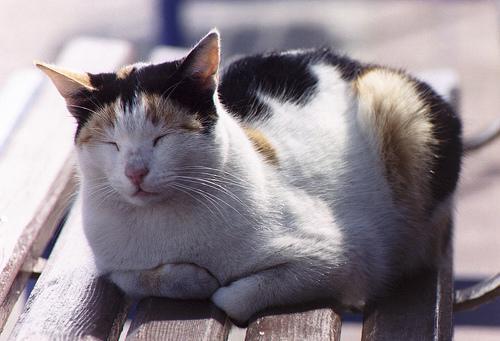How many cats are there?
Give a very brief answer. 1. 